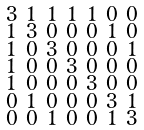Convert formula to latex. <formula><loc_0><loc_0><loc_500><loc_500>\begin{smallmatrix} 3 & 1 & 1 & 1 & 1 & 0 & 0 \\ 1 & 3 & 0 & 0 & 0 & 1 & 0 \\ 1 & 0 & 3 & 0 & 0 & 0 & 1 \\ 1 & 0 & 0 & 3 & 0 & 0 & 0 \\ 1 & 0 & 0 & 0 & 3 & 0 & 0 \\ 0 & 1 & 0 & 0 & 0 & 3 & 1 \\ 0 & 0 & 1 & 0 & 0 & 1 & 3 \end{smallmatrix}</formula> 